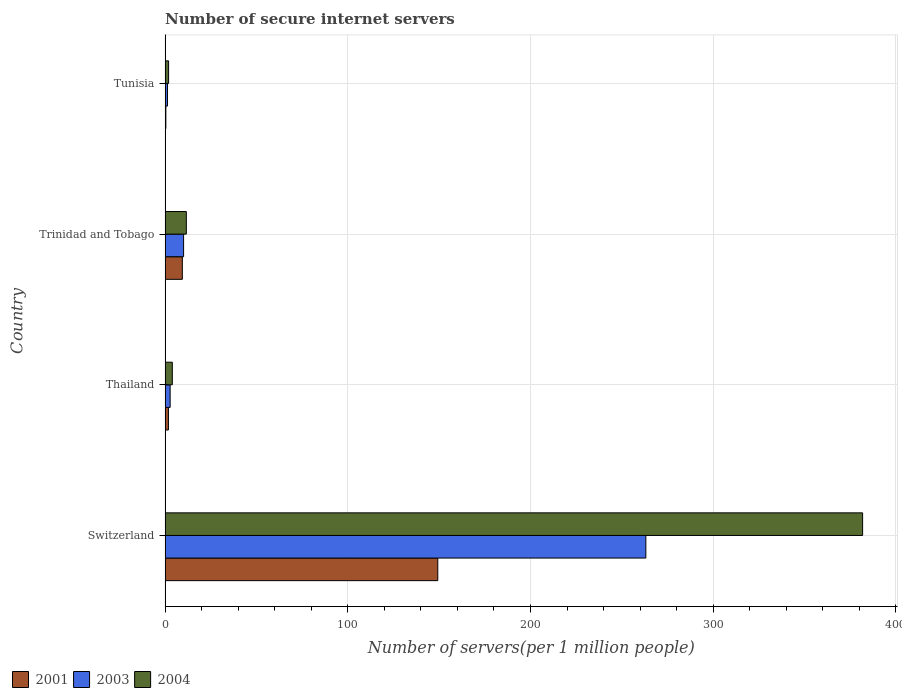Are the number of bars on each tick of the Y-axis equal?
Your response must be concise. Yes. What is the label of the 1st group of bars from the top?
Make the answer very short. Tunisia. In how many cases, is the number of bars for a given country not equal to the number of legend labels?
Give a very brief answer. 0. What is the number of secure internet servers in 2001 in Thailand?
Provide a short and direct response. 1.83. Across all countries, what is the maximum number of secure internet servers in 2003?
Your answer should be very brief. 263.11. Across all countries, what is the minimum number of secure internet servers in 2003?
Give a very brief answer. 1.32. In which country was the number of secure internet servers in 2001 maximum?
Offer a very short reply. Switzerland. In which country was the number of secure internet servers in 2004 minimum?
Offer a very short reply. Tunisia. What is the total number of secure internet servers in 2001 in the graph?
Offer a very short reply. 160.92. What is the difference between the number of secure internet servers in 2001 in Switzerland and that in Thailand?
Give a very brief answer. 147.41. What is the difference between the number of secure internet servers in 2003 in Tunisia and the number of secure internet servers in 2004 in Switzerland?
Ensure brevity in your answer.  -380.43. What is the average number of secure internet servers in 2001 per country?
Offer a terse response. 40.23. What is the difference between the number of secure internet servers in 2004 and number of secure internet servers in 2003 in Tunisia?
Ensure brevity in your answer.  0.59. What is the ratio of the number of secure internet servers in 2003 in Switzerland to that in Tunisia?
Ensure brevity in your answer.  199.15. Is the number of secure internet servers in 2003 in Thailand less than that in Tunisia?
Keep it short and to the point. No. What is the difference between the highest and the second highest number of secure internet servers in 2004?
Offer a very short reply. 370.13. What is the difference between the highest and the lowest number of secure internet servers in 2003?
Offer a very short reply. 261.79. Is the sum of the number of secure internet servers in 2004 in Switzerland and Tunisia greater than the maximum number of secure internet servers in 2003 across all countries?
Your answer should be very brief. Yes. Is it the case that in every country, the sum of the number of secure internet servers in 2004 and number of secure internet servers in 2003 is greater than the number of secure internet servers in 2001?
Make the answer very short. Yes. Are all the bars in the graph horizontal?
Your response must be concise. Yes. Does the graph contain any zero values?
Ensure brevity in your answer.  No. What is the title of the graph?
Give a very brief answer. Number of secure internet servers. What is the label or title of the X-axis?
Your answer should be very brief. Number of servers(per 1 million people). What is the label or title of the Y-axis?
Make the answer very short. Country. What is the Number of servers(per 1 million people) of 2001 in Switzerland?
Give a very brief answer. 149.24. What is the Number of servers(per 1 million people) of 2003 in Switzerland?
Make the answer very short. 263.11. What is the Number of servers(per 1 million people) of 2004 in Switzerland?
Your answer should be compact. 381.75. What is the Number of servers(per 1 million people) in 2001 in Thailand?
Make the answer very short. 1.83. What is the Number of servers(per 1 million people) in 2003 in Thailand?
Make the answer very short. 2.76. What is the Number of servers(per 1 million people) in 2004 in Thailand?
Provide a succinct answer. 3.94. What is the Number of servers(per 1 million people) in 2001 in Trinidad and Tobago?
Keep it short and to the point. 9.43. What is the Number of servers(per 1 million people) of 2003 in Trinidad and Tobago?
Make the answer very short. 10.12. What is the Number of servers(per 1 million people) of 2004 in Trinidad and Tobago?
Offer a very short reply. 11.62. What is the Number of servers(per 1 million people) in 2001 in Tunisia?
Give a very brief answer. 0.41. What is the Number of servers(per 1 million people) in 2003 in Tunisia?
Your response must be concise. 1.32. What is the Number of servers(per 1 million people) in 2004 in Tunisia?
Your answer should be very brief. 1.91. Across all countries, what is the maximum Number of servers(per 1 million people) of 2001?
Your answer should be very brief. 149.24. Across all countries, what is the maximum Number of servers(per 1 million people) in 2003?
Offer a terse response. 263.11. Across all countries, what is the maximum Number of servers(per 1 million people) in 2004?
Your response must be concise. 381.75. Across all countries, what is the minimum Number of servers(per 1 million people) in 2001?
Offer a terse response. 0.41. Across all countries, what is the minimum Number of servers(per 1 million people) in 2003?
Make the answer very short. 1.32. Across all countries, what is the minimum Number of servers(per 1 million people) in 2004?
Your answer should be compact. 1.91. What is the total Number of servers(per 1 million people) of 2001 in the graph?
Your answer should be very brief. 160.92. What is the total Number of servers(per 1 million people) in 2003 in the graph?
Your answer should be very brief. 277.32. What is the total Number of servers(per 1 million people) of 2004 in the graph?
Give a very brief answer. 399.23. What is the difference between the Number of servers(per 1 million people) of 2001 in Switzerland and that in Thailand?
Your answer should be very brief. 147.41. What is the difference between the Number of servers(per 1 million people) in 2003 in Switzerland and that in Thailand?
Your answer should be compact. 260.35. What is the difference between the Number of servers(per 1 million people) of 2004 in Switzerland and that in Thailand?
Provide a short and direct response. 377.81. What is the difference between the Number of servers(per 1 million people) in 2001 in Switzerland and that in Trinidad and Tobago?
Your answer should be compact. 139.81. What is the difference between the Number of servers(per 1 million people) in 2003 in Switzerland and that in Trinidad and Tobago?
Provide a succinct answer. 252.99. What is the difference between the Number of servers(per 1 million people) of 2004 in Switzerland and that in Trinidad and Tobago?
Provide a succinct answer. 370.13. What is the difference between the Number of servers(per 1 million people) in 2001 in Switzerland and that in Tunisia?
Provide a short and direct response. 148.83. What is the difference between the Number of servers(per 1 million people) in 2003 in Switzerland and that in Tunisia?
Provide a succinct answer. 261.79. What is the difference between the Number of servers(per 1 million people) in 2004 in Switzerland and that in Tunisia?
Make the answer very short. 379.84. What is the difference between the Number of servers(per 1 million people) of 2001 in Thailand and that in Trinidad and Tobago?
Provide a succinct answer. -7.6. What is the difference between the Number of servers(per 1 million people) in 2003 in Thailand and that in Trinidad and Tobago?
Offer a terse response. -7.36. What is the difference between the Number of servers(per 1 million people) in 2004 in Thailand and that in Trinidad and Tobago?
Ensure brevity in your answer.  -7.68. What is the difference between the Number of servers(per 1 million people) of 2001 in Thailand and that in Tunisia?
Provide a succinct answer. 1.41. What is the difference between the Number of servers(per 1 million people) of 2003 in Thailand and that in Tunisia?
Give a very brief answer. 1.44. What is the difference between the Number of servers(per 1 million people) of 2004 in Thailand and that in Tunisia?
Your answer should be compact. 2.03. What is the difference between the Number of servers(per 1 million people) of 2001 in Trinidad and Tobago and that in Tunisia?
Your answer should be very brief. 9.02. What is the difference between the Number of servers(per 1 million people) in 2003 in Trinidad and Tobago and that in Tunisia?
Your answer should be very brief. 8.8. What is the difference between the Number of servers(per 1 million people) in 2004 in Trinidad and Tobago and that in Tunisia?
Your answer should be very brief. 9.71. What is the difference between the Number of servers(per 1 million people) in 2001 in Switzerland and the Number of servers(per 1 million people) in 2003 in Thailand?
Your response must be concise. 146.48. What is the difference between the Number of servers(per 1 million people) in 2001 in Switzerland and the Number of servers(per 1 million people) in 2004 in Thailand?
Your answer should be compact. 145.3. What is the difference between the Number of servers(per 1 million people) in 2003 in Switzerland and the Number of servers(per 1 million people) in 2004 in Thailand?
Keep it short and to the point. 259.17. What is the difference between the Number of servers(per 1 million people) in 2001 in Switzerland and the Number of servers(per 1 million people) in 2003 in Trinidad and Tobago?
Keep it short and to the point. 139.12. What is the difference between the Number of servers(per 1 million people) of 2001 in Switzerland and the Number of servers(per 1 million people) of 2004 in Trinidad and Tobago?
Your response must be concise. 137.62. What is the difference between the Number of servers(per 1 million people) of 2003 in Switzerland and the Number of servers(per 1 million people) of 2004 in Trinidad and Tobago?
Give a very brief answer. 251.49. What is the difference between the Number of servers(per 1 million people) in 2001 in Switzerland and the Number of servers(per 1 million people) in 2003 in Tunisia?
Offer a terse response. 147.92. What is the difference between the Number of servers(per 1 million people) in 2001 in Switzerland and the Number of servers(per 1 million people) in 2004 in Tunisia?
Make the answer very short. 147.33. What is the difference between the Number of servers(per 1 million people) of 2003 in Switzerland and the Number of servers(per 1 million people) of 2004 in Tunisia?
Your answer should be compact. 261.2. What is the difference between the Number of servers(per 1 million people) in 2001 in Thailand and the Number of servers(per 1 million people) in 2003 in Trinidad and Tobago?
Offer a terse response. -8.29. What is the difference between the Number of servers(per 1 million people) in 2001 in Thailand and the Number of servers(per 1 million people) in 2004 in Trinidad and Tobago?
Make the answer very short. -9.79. What is the difference between the Number of servers(per 1 million people) of 2003 in Thailand and the Number of servers(per 1 million people) of 2004 in Trinidad and Tobago?
Your answer should be compact. -8.86. What is the difference between the Number of servers(per 1 million people) in 2001 in Thailand and the Number of servers(per 1 million people) in 2003 in Tunisia?
Offer a very short reply. 0.51. What is the difference between the Number of servers(per 1 million people) in 2001 in Thailand and the Number of servers(per 1 million people) in 2004 in Tunisia?
Provide a succinct answer. -0.08. What is the difference between the Number of servers(per 1 million people) in 2003 in Thailand and the Number of servers(per 1 million people) in 2004 in Tunisia?
Your answer should be very brief. 0.85. What is the difference between the Number of servers(per 1 million people) of 2001 in Trinidad and Tobago and the Number of servers(per 1 million people) of 2003 in Tunisia?
Your response must be concise. 8.11. What is the difference between the Number of servers(per 1 million people) in 2001 in Trinidad and Tobago and the Number of servers(per 1 million people) in 2004 in Tunisia?
Keep it short and to the point. 7.52. What is the difference between the Number of servers(per 1 million people) in 2003 in Trinidad and Tobago and the Number of servers(per 1 million people) in 2004 in Tunisia?
Offer a very short reply. 8.21. What is the average Number of servers(per 1 million people) of 2001 per country?
Give a very brief answer. 40.23. What is the average Number of servers(per 1 million people) in 2003 per country?
Your answer should be very brief. 69.33. What is the average Number of servers(per 1 million people) of 2004 per country?
Provide a short and direct response. 99.81. What is the difference between the Number of servers(per 1 million people) of 2001 and Number of servers(per 1 million people) of 2003 in Switzerland?
Your answer should be compact. -113.87. What is the difference between the Number of servers(per 1 million people) in 2001 and Number of servers(per 1 million people) in 2004 in Switzerland?
Provide a succinct answer. -232.51. What is the difference between the Number of servers(per 1 million people) in 2003 and Number of servers(per 1 million people) in 2004 in Switzerland?
Offer a terse response. -118.64. What is the difference between the Number of servers(per 1 million people) of 2001 and Number of servers(per 1 million people) of 2003 in Thailand?
Keep it short and to the point. -0.93. What is the difference between the Number of servers(per 1 million people) of 2001 and Number of servers(per 1 million people) of 2004 in Thailand?
Your response must be concise. -2.12. What is the difference between the Number of servers(per 1 million people) of 2003 and Number of servers(per 1 million people) of 2004 in Thailand?
Ensure brevity in your answer.  -1.18. What is the difference between the Number of servers(per 1 million people) of 2001 and Number of servers(per 1 million people) of 2003 in Trinidad and Tobago?
Keep it short and to the point. -0.69. What is the difference between the Number of servers(per 1 million people) of 2001 and Number of servers(per 1 million people) of 2004 in Trinidad and Tobago?
Provide a short and direct response. -2.19. What is the difference between the Number of servers(per 1 million people) of 2003 and Number of servers(per 1 million people) of 2004 in Trinidad and Tobago?
Ensure brevity in your answer.  -1.5. What is the difference between the Number of servers(per 1 million people) in 2001 and Number of servers(per 1 million people) in 2003 in Tunisia?
Offer a very short reply. -0.91. What is the difference between the Number of servers(per 1 million people) of 2001 and Number of servers(per 1 million people) of 2004 in Tunisia?
Offer a very short reply. -1.5. What is the difference between the Number of servers(per 1 million people) in 2003 and Number of servers(per 1 million people) in 2004 in Tunisia?
Offer a very short reply. -0.59. What is the ratio of the Number of servers(per 1 million people) of 2001 in Switzerland to that in Thailand?
Your response must be concise. 81.59. What is the ratio of the Number of servers(per 1 million people) in 2003 in Switzerland to that in Thailand?
Make the answer very short. 95.28. What is the ratio of the Number of servers(per 1 million people) in 2004 in Switzerland to that in Thailand?
Your response must be concise. 96.78. What is the ratio of the Number of servers(per 1 million people) in 2001 in Switzerland to that in Trinidad and Tobago?
Your answer should be compact. 15.82. What is the ratio of the Number of servers(per 1 million people) of 2003 in Switzerland to that in Trinidad and Tobago?
Keep it short and to the point. 25.99. What is the ratio of the Number of servers(per 1 million people) of 2004 in Switzerland to that in Trinidad and Tobago?
Give a very brief answer. 32.84. What is the ratio of the Number of servers(per 1 million people) of 2001 in Switzerland to that in Tunisia?
Make the answer very short. 360.07. What is the ratio of the Number of servers(per 1 million people) of 2003 in Switzerland to that in Tunisia?
Provide a succinct answer. 199.15. What is the ratio of the Number of servers(per 1 million people) of 2004 in Switzerland to that in Tunisia?
Offer a terse response. 199.56. What is the ratio of the Number of servers(per 1 million people) in 2001 in Thailand to that in Trinidad and Tobago?
Provide a short and direct response. 0.19. What is the ratio of the Number of servers(per 1 million people) of 2003 in Thailand to that in Trinidad and Tobago?
Make the answer very short. 0.27. What is the ratio of the Number of servers(per 1 million people) in 2004 in Thailand to that in Trinidad and Tobago?
Give a very brief answer. 0.34. What is the ratio of the Number of servers(per 1 million people) in 2001 in Thailand to that in Tunisia?
Make the answer very short. 4.41. What is the ratio of the Number of servers(per 1 million people) of 2003 in Thailand to that in Tunisia?
Provide a short and direct response. 2.09. What is the ratio of the Number of servers(per 1 million people) in 2004 in Thailand to that in Tunisia?
Offer a terse response. 2.06. What is the ratio of the Number of servers(per 1 million people) in 2001 in Trinidad and Tobago to that in Tunisia?
Provide a succinct answer. 22.75. What is the ratio of the Number of servers(per 1 million people) in 2003 in Trinidad and Tobago to that in Tunisia?
Provide a short and direct response. 7.66. What is the ratio of the Number of servers(per 1 million people) of 2004 in Trinidad and Tobago to that in Tunisia?
Your response must be concise. 6.08. What is the difference between the highest and the second highest Number of servers(per 1 million people) of 2001?
Your response must be concise. 139.81. What is the difference between the highest and the second highest Number of servers(per 1 million people) of 2003?
Your response must be concise. 252.99. What is the difference between the highest and the second highest Number of servers(per 1 million people) in 2004?
Keep it short and to the point. 370.13. What is the difference between the highest and the lowest Number of servers(per 1 million people) in 2001?
Make the answer very short. 148.83. What is the difference between the highest and the lowest Number of servers(per 1 million people) of 2003?
Make the answer very short. 261.79. What is the difference between the highest and the lowest Number of servers(per 1 million people) in 2004?
Provide a succinct answer. 379.84. 